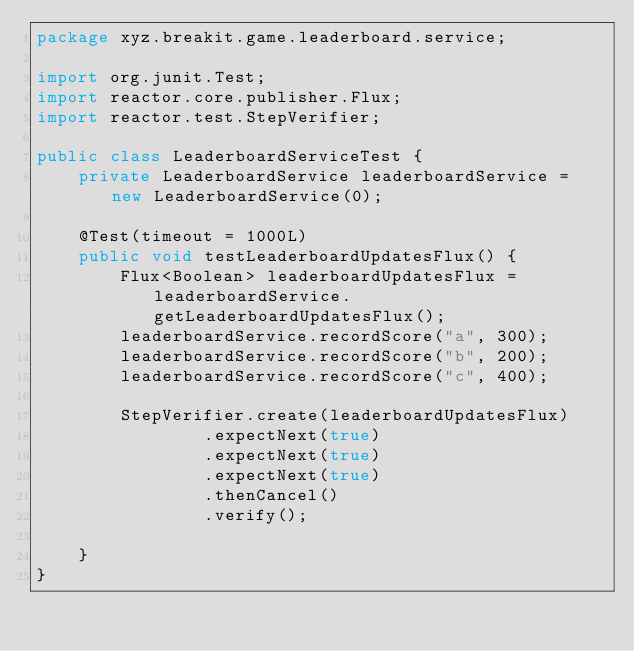Convert code to text. <code><loc_0><loc_0><loc_500><loc_500><_Java_>package xyz.breakit.game.leaderboard.service;

import org.junit.Test;
import reactor.core.publisher.Flux;
import reactor.test.StepVerifier;

public class LeaderboardServiceTest {
    private LeaderboardService leaderboardService = new LeaderboardService(0);

    @Test(timeout = 1000L)
    public void testLeaderboardUpdatesFlux() {
        Flux<Boolean> leaderboardUpdatesFlux = leaderboardService.getLeaderboardUpdatesFlux();
        leaderboardService.recordScore("a", 300);
        leaderboardService.recordScore("b", 200);
        leaderboardService.recordScore("c", 400);

        StepVerifier.create(leaderboardUpdatesFlux)
                .expectNext(true)
                .expectNext(true)
                .expectNext(true)
                .thenCancel()
                .verify();

    }
}</code> 